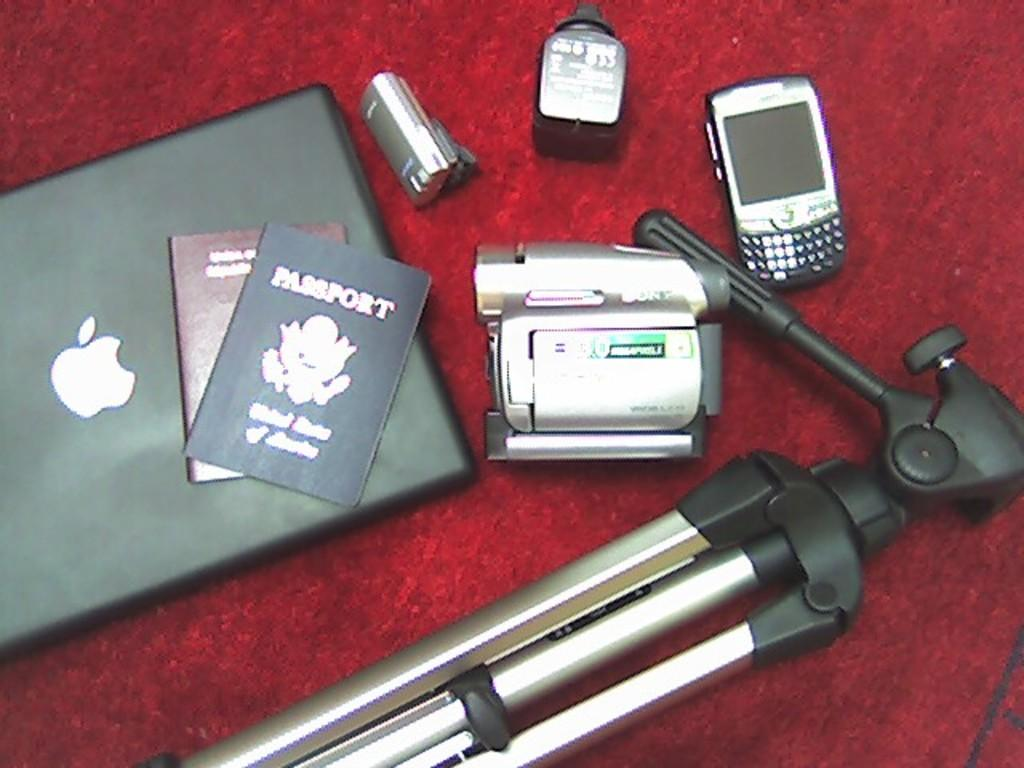<image>
Describe the image concisely. Sitting on a apple laptop is two passports with electronic devices and accessories surrounding them. 